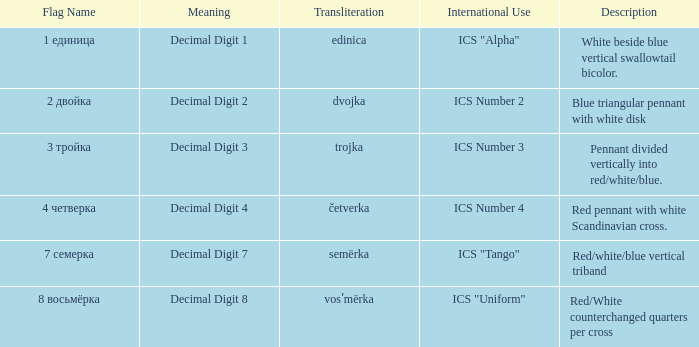What are the meanings of the flag whose name transliterates to semërka? Decimal Digit 7. Write the full table. {'header': ['Flag Name', 'Meaning', 'Transliteration', 'International Use', 'Description'], 'rows': [['1 единица', 'Decimal Digit 1', 'edinica', 'ICS "Alpha"', 'White beside blue vertical swallowtail bicolor.'], ['2 двойка', 'Decimal Digit 2', 'dvojka', 'ICS Number 2', 'Blue triangular pennant with white disk'], ['3 тройка', 'Decimal Digit 3', 'trojka', 'ICS Number 3', 'Pennant divided vertically into red/white/blue.'], ['4 четверка', 'Decimal Digit 4', 'četverka', 'ICS Number 4', 'Red pennant with white Scandinavian cross.'], ['7 семерка', 'Decimal Digit 7', 'semërka', 'ICS "Tango"', 'Red/white/blue vertical triband'], ['8 восьмёрка', 'Decimal Digit 8', 'vosʹmërka', 'ICS "Uniform"', 'Red/White counterchanged quarters per cross']]} 